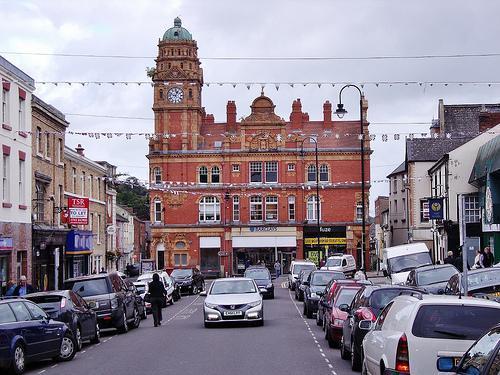How many cars are driving down the street?
Give a very brief answer. 2. How many cars are parked on the left?
Give a very brief answer. 6. How many lines are hanging from the buildings?
Give a very brief answer. 7. 